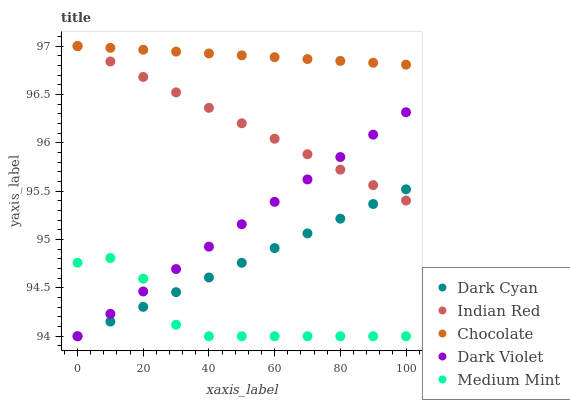Does Medium Mint have the minimum area under the curve?
Answer yes or no. Yes. Does Chocolate have the maximum area under the curve?
Answer yes or no. Yes. Does Dark Violet have the minimum area under the curve?
Answer yes or no. No. Does Dark Violet have the maximum area under the curve?
Answer yes or no. No. Is Dark Cyan the smoothest?
Answer yes or no. Yes. Is Medium Mint the roughest?
Answer yes or no. Yes. Is Dark Violet the smoothest?
Answer yes or no. No. Is Dark Violet the roughest?
Answer yes or no. No. Does Dark Cyan have the lowest value?
Answer yes or no. Yes. Does Indian Red have the lowest value?
Answer yes or no. No. Does Chocolate have the highest value?
Answer yes or no. Yes. Does Dark Violet have the highest value?
Answer yes or no. No. Is Medium Mint less than Indian Red?
Answer yes or no. Yes. Is Chocolate greater than Dark Violet?
Answer yes or no. Yes. Does Indian Red intersect Dark Violet?
Answer yes or no. Yes. Is Indian Red less than Dark Violet?
Answer yes or no. No. Is Indian Red greater than Dark Violet?
Answer yes or no. No. Does Medium Mint intersect Indian Red?
Answer yes or no. No. 